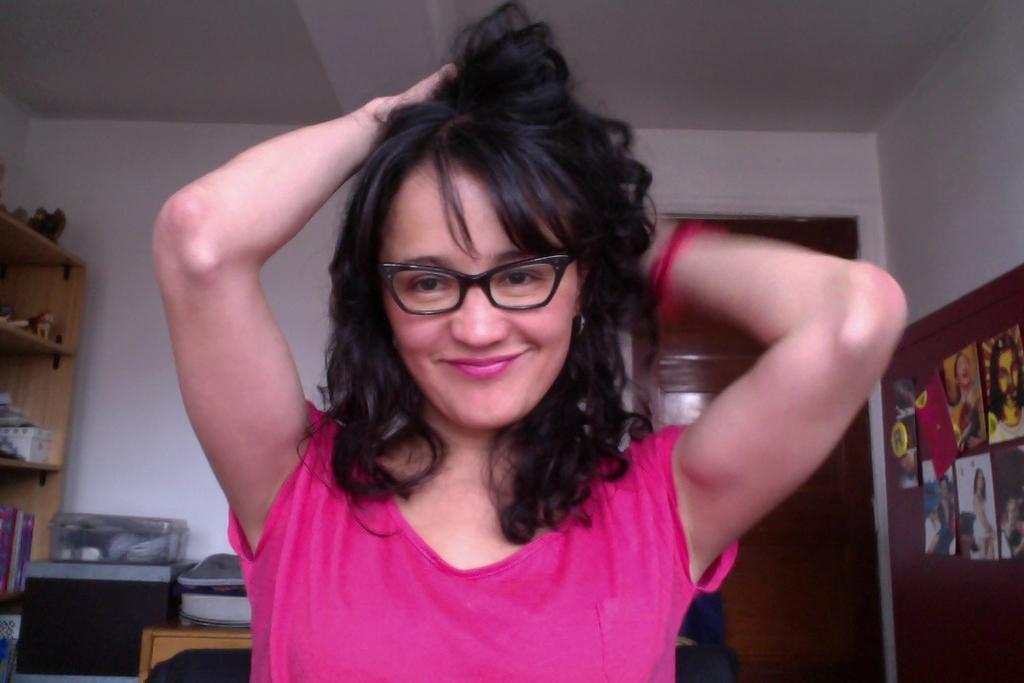Describe this image in one or two sentences. In this image I see a woman who is wearing pink top and I see that she is smiling. In the background I see the wall and I see few posters over here and I see few things on the racks and I see few more things over here. 